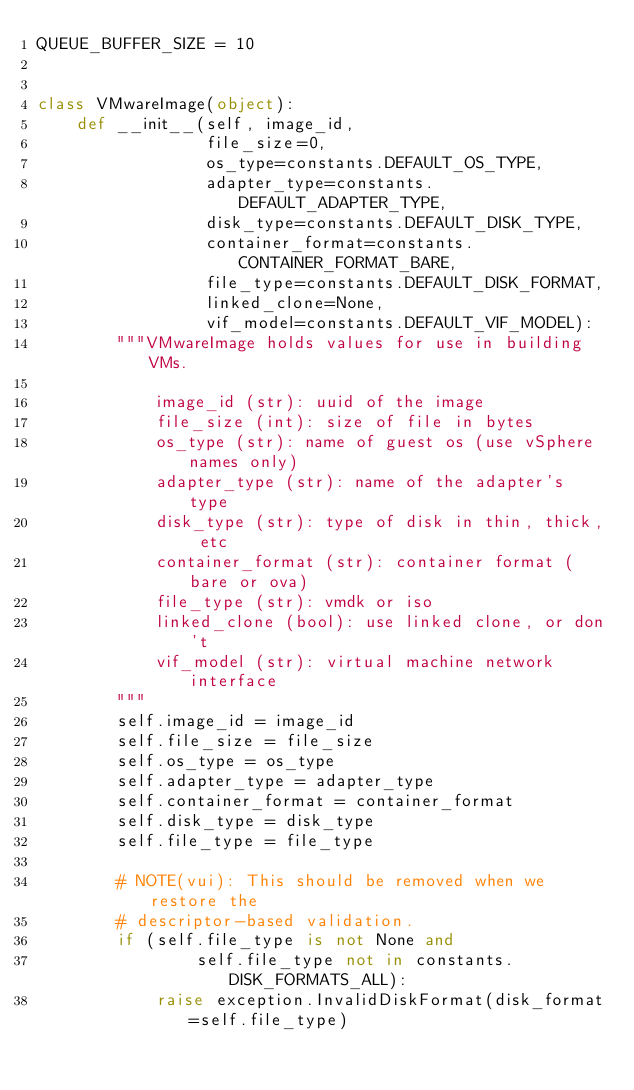Convert code to text. <code><loc_0><loc_0><loc_500><loc_500><_Python_>QUEUE_BUFFER_SIZE = 10


class VMwareImage(object):
    def __init__(self, image_id,
                 file_size=0,
                 os_type=constants.DEFAULT_OS_TYPE,
                 adapter_type=constants.DEFAULT_ADAPTER_TYPE,
                 disk_type=constants.DEFAULT_DISK_TYPE,
                 container_format=constants.CONTAINER_FORMAT_BARE,
                 file_type=constants.DEFAULT_DISK_FORMAT,
                 linked_clone=None,
                 vif_model=constants.DEFAULT_VIF_MODEL):
        """VMwareImage holds values for use in building VMs.

            image_id (str): uuid of the image
            file_size (int): size of file in bytes
            os_type (str): name of guest os (use vSphere names only)
            adapter_type (str): name of the adapter's type
            disk_type (str): type of disk in thin, thick, etc
            container_format (str): container format (bare or ova)
            file_type (str): vmdk or iso
            linked_clone (bool): use linked clone, or don't
            vif_model (str): virtual machine network interface
        """
        self.image_id = image_id
        self.file_size = file_size
        self.os_type = os_type
        self.adapter_type = adapter_type
        self.container_format = container_format
        self.disk_type = disk_type
        self.file_type = file_type

        # NOTE(vui): This should be removed when we restore the
        # descriptor-based validation.
        if (self.file_type is not None and
                self.file_type not in constants.DISK_FORMATS_ALL):
            raise exception.InvalidDiskFormat(disk_format=self.file_type)
</code> 